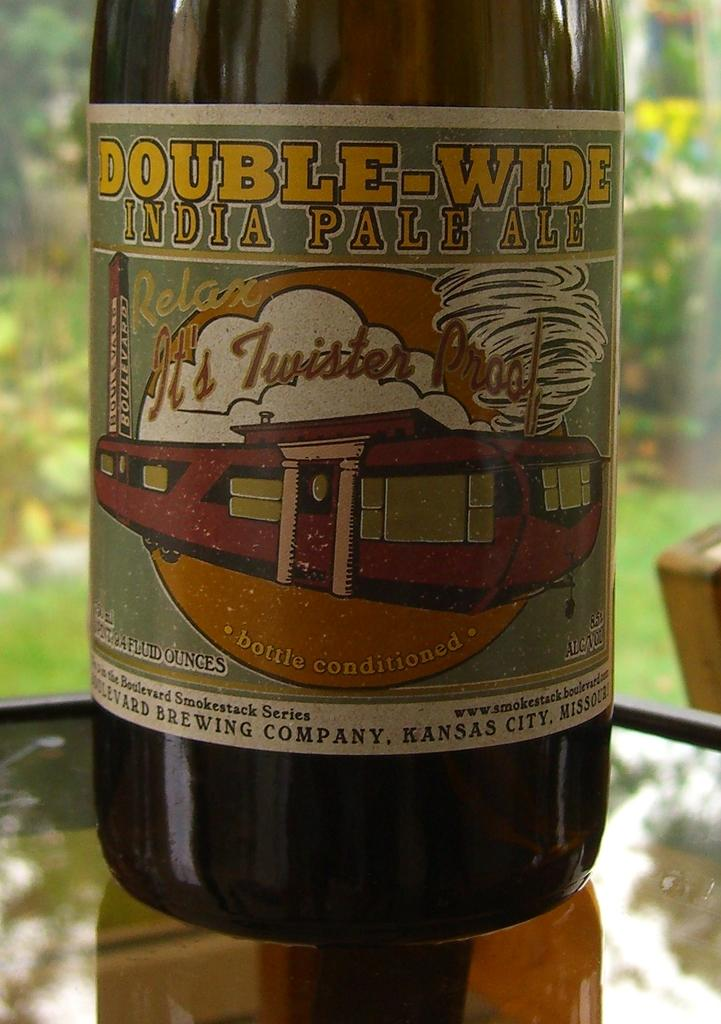<image>
Render a clear and concise summary of the photo. A bottle of Double-Wide IPA has a mobile home on the label. 